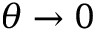Convert formula to latex. <formula><loc_0><loc_0><loc_500><loc_500>\theta \to 0</formula> 